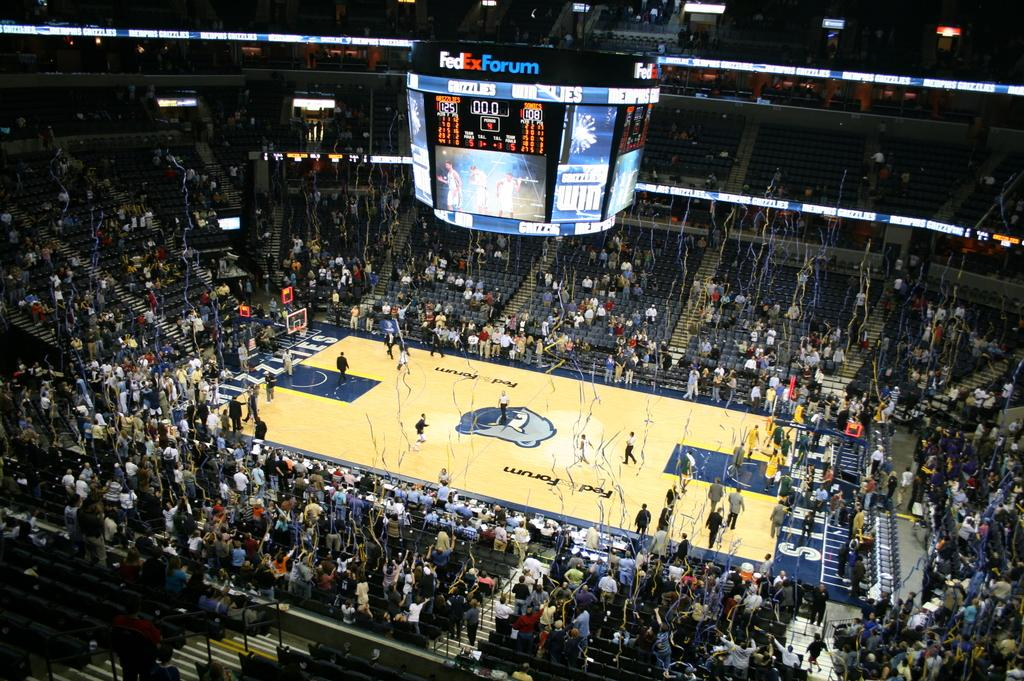<image>
Create a compact narrative representing the image presented. Streamers are falling from the ceiling in the FedEx Forum after a game. 